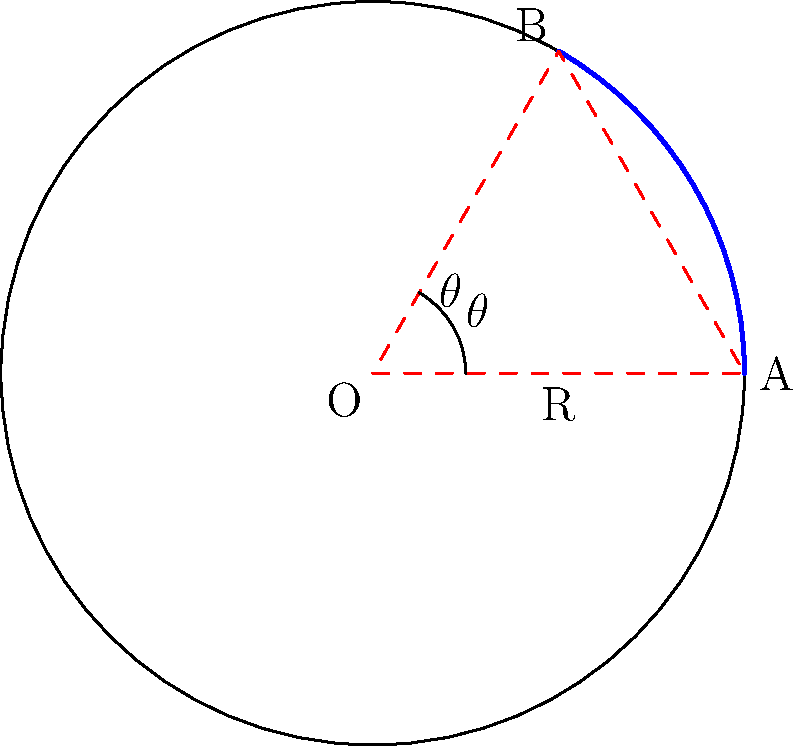In the context of non-Euclidean geometry on a sphere's surface, how does the distance between two points A and B compare to the length of the straight line connecting them in Euclidean space? Consider this in relation to the curvature of the Earth and its impact on GPS measurements for oil field locations. To understand this concept, let's break it down step-by-step:

1) In Euclidean geometry, the shortest distance between two points is a straight line. However, on a curved surface like a sphere (which represents the Earth in this case), this is not true.

2) On a sphere, the shortest distance between two points is along a great circle, which is the intersection of the sphere with a plane passing through the center of the sphere and both points.

3) In the diagram, the arc AB represents the shortest path between A and B on the sphere's surface, while the straight line AB represents the Euclidean distance.

4) The length of the arc AB is calculated as:

   $$s = R\theta$$

   Where $R$ is the radius of the sphere and $\theta$ is the central angle in radians.

5) The Euclidean distance (chord length) is calculated as:

   $$d = 2R\sin(\frac{\theta}{2})$$

6) For small angles, the arc length and chord length are very close. But as the angle increases, the difference becomes more significant.

7) In the context of GPS measurements for oil field locations in Texas:
   - For short distances, the difference between the curved and straight-line distance is negligible.
   - For longer distances (e.g., across large oil fields), the curvature of the Earth becomes more significant, and the GPS must account for this to provide accurate measurements.

8) This is why GPS systems and other mapping technologies use complex algorithms to translate the curved surface of the Earth onto flat maps and to calculate accurate distances and routes.
Answer: The distance along the curved surface (arc) is always longer than the straight-line (chord) distance in Euclidean space, with the difference increasing for larger distances. 